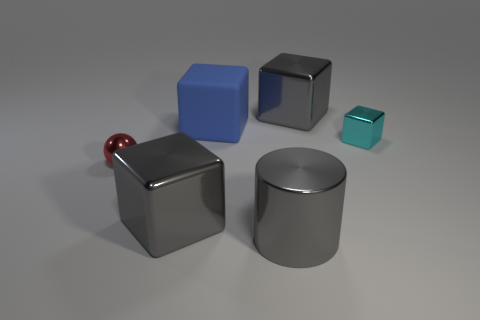Subtract 1 blocks. How many blocks are left? 3 Add 3 gray metallic blocks. How many objects exist? 9 Subtract all cylinders. How many objects are left? 5 Subtract all big gray cubes. Subtract all large gray metallic blocks. How many objects are left? 2 Add 6 big gray metal cylinders. How many big gray metal cylinders are left? 7 Add 4 blue things. How many blue things exist? 5 Subtract 1 blue blocks. How many objects are left? 5 